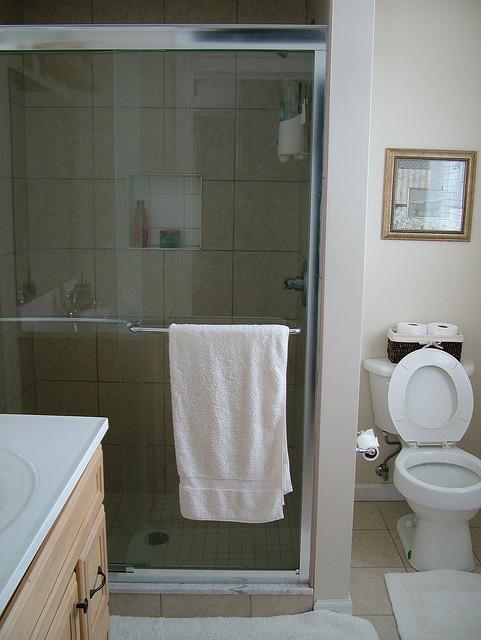How many toilet paper rolls are visible?
Give a very brief answer. 3. How many toilets can be seen?
Give a very brief answer. 1. 